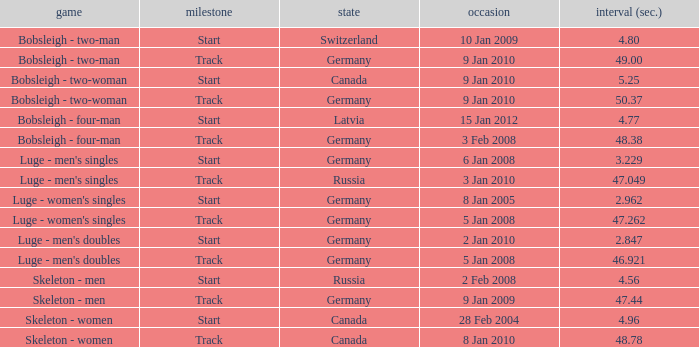Which nation finished with a time of 47.049? Russia. 